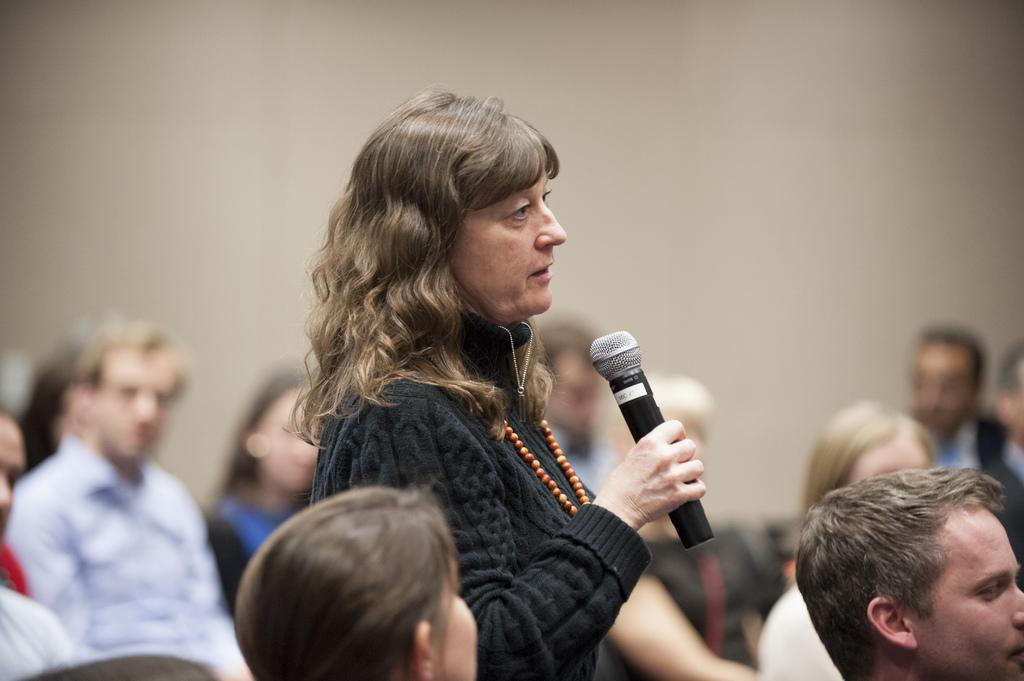What is the woman in the image holding? The woman is holding a mic in her hand. What is the woman wearing in the image? The woman is wearing a black dress. What can be seen in the background of the image? There are people sitting in the background of the image, and there is a wall visible. What type of ticket is the woman holding in the image? The woman is not holding a ticket in the image; she is holding a mic. What substance is the woman using to perform in the image? There is no substance mentioned or visible in the image; the woman is holding a mic and wearing a black dress. 